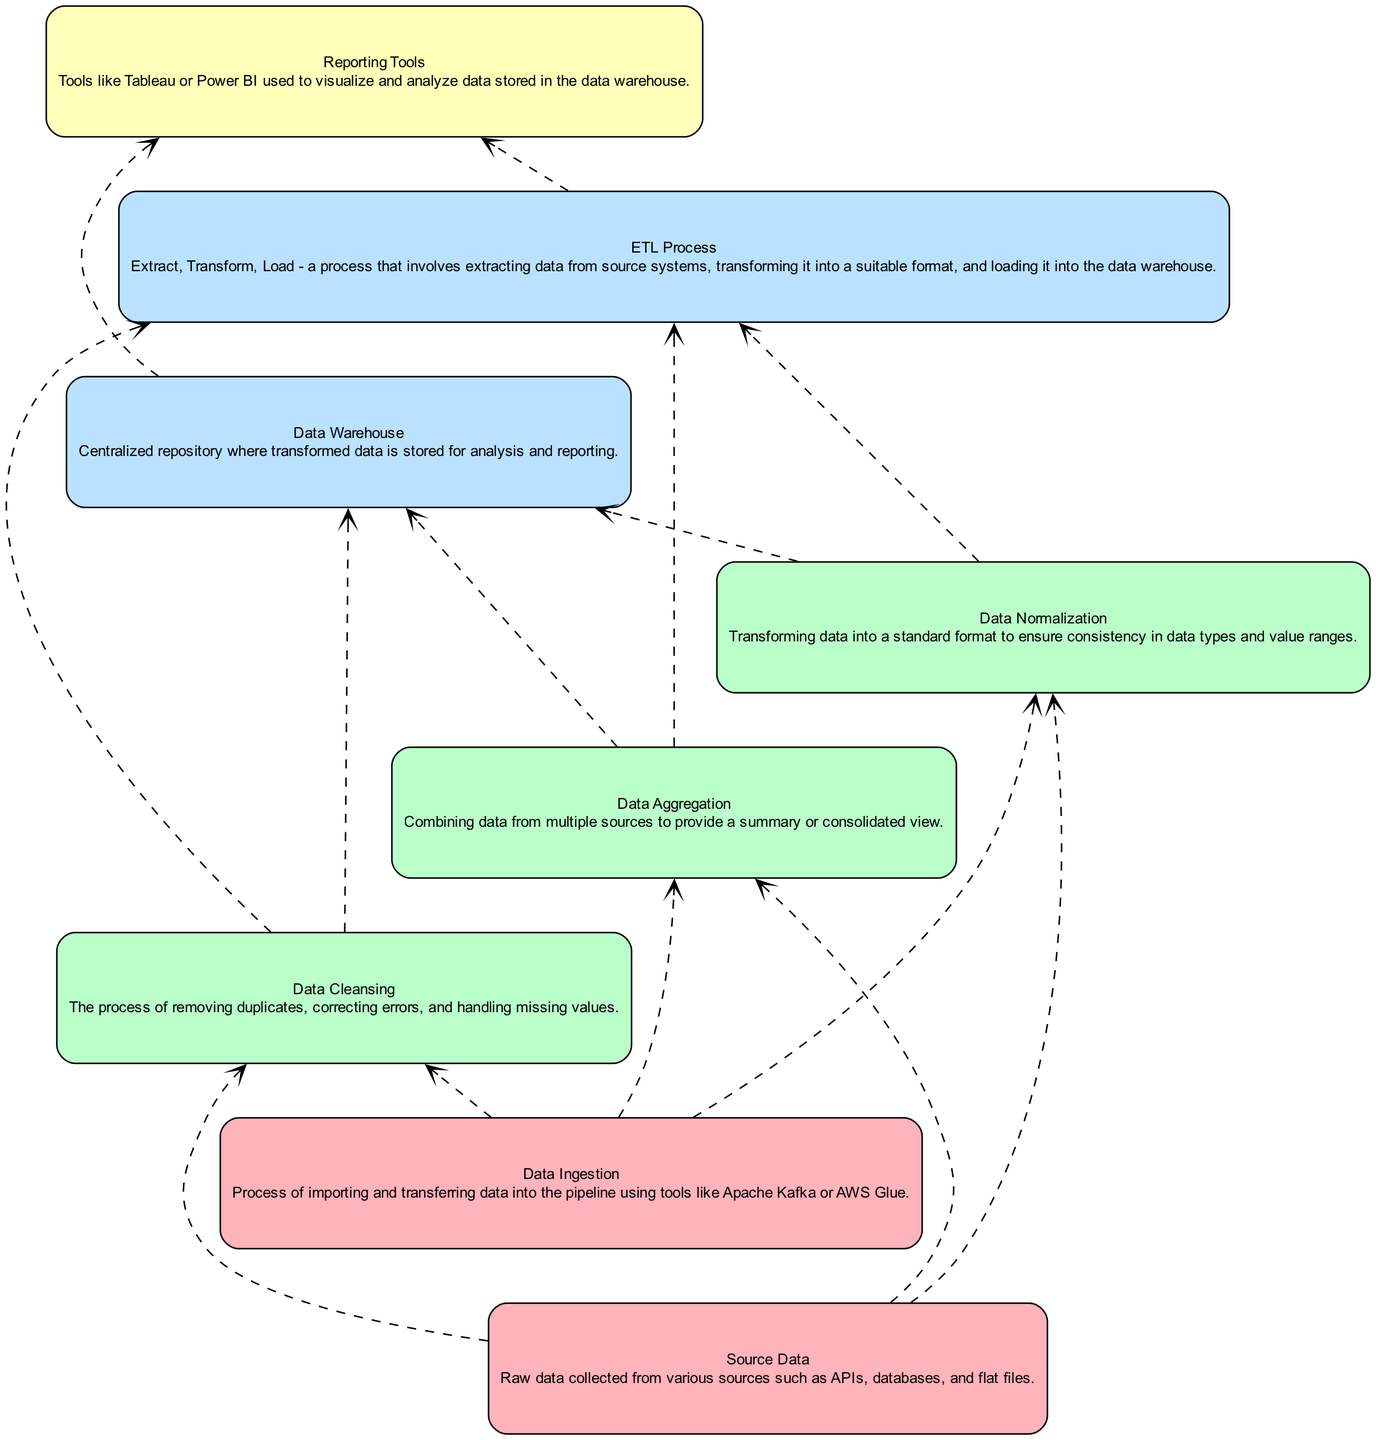What is the first stage in the data pipeline? The first stage is "Data Gathering," where data is collected. The diagram starts from the bottom, indicating the flow begins at this stage.
Answer: Data Gathering How many types of data transformation processes are there? The diagram lists three types under "Data Transformation": Data Cleansing, Data Aggregation, and Data Normalization. Counting these gives a total of three processes.
Answer: 3 What connects "Data Normalization" to "Data Warehouse"? The connection is established through the ETL Process. The diagram shows an edge linking "Data Normalization" (a transformation step) to "ETL Process," which in turn leads to "Data Warehouse."
Answer: ETL Process Which tool is mentioned for data visualization? The diagram specifies "Reporting Tools" such as Tableau or Power BI for visualizing data. These tools are situated in the data analysis stage of the pipeline.
Answer: Reporting Tools Which processes precede data loading? The processes preceding data loading are all the steps under "Data Transformation," specifically: Data Cleansing, Data Aggregation, and Data Normalization. Each must be completed before reaching the "Data Warehouse."
Answer: Data Cleansing, Data Aggregation, Data Normalization How many nodes are present in the Data Loading stage? The Data Loading stage consists of two nodes: "Data Warehouse" and "ETL Process." Counting these nodes confirms that there are two elements in this stage.
Answer: 2 What is the overall flow direction of this diagram? The overall flow direction is from bottom to top. The diagram is specifically oriented as a bottom-up flow chart, illustrating the stages of the data pipeline from gathering up to analysis.
Answer: Bottom to top Which stage includes the step of data ingestion? "Data Gathering" includes the step of data ingestion. The diagram categorizes this step under the data gathering activities.
Answer: Data Gathering Which two stages are directly connected by a dashed edge? The "Data Transformation" and "Data Loading" stages are directly connected by a dashed edge, indicating the flow between these two critical phases of processing data.
Answer: Data Transformation, Data Loading 